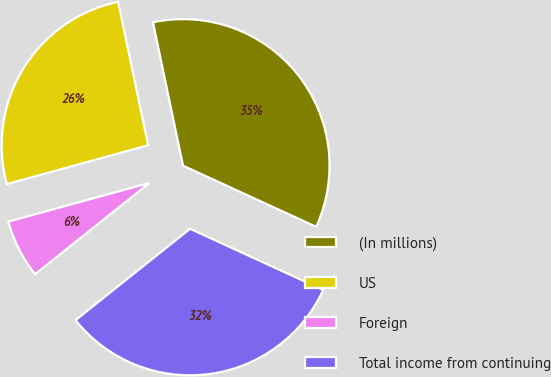Convert chart to OTSL. <chart><loc_0><loc_0><loc_500><loc_500><pie_chart><fcel>(In millions)<fcel>US<fcel>Foreign<fcel>Total income from continuing<nl><fcel>35.14%<fcel>25.98%<fcel>6.45%<fcel>32.43%<nl></chart> 